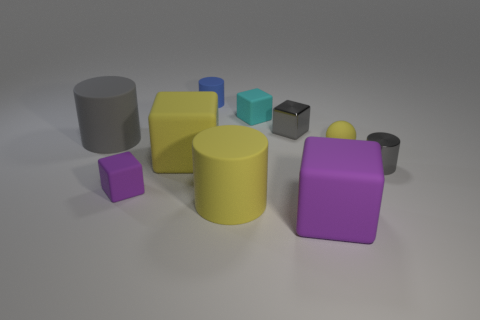Subtract all yellow cylinders. How many cylinders are left? 3 Subtract all yellow balls. How many purple blocks are left? 2 Subtract 1 cubes. How many cubes are left? 4 Subtract all yellow blocks. How many blocks are left? 4 Subtract all brown cylinders. Subtract all brown balls. How many cylinders are left? 4 Subtract all balls. How many objects are left? 9 Add 9 large yellow cylinders. How many large yellow cylinders are left? 10 Add 1 green matte cylinders. How many green matte cylinders exist? 1 Subtract 0 green cylinders. How many objects are left? 10 Subtract all tiny gray cylinders. Subtract all spheres. How many objects are left? 8 